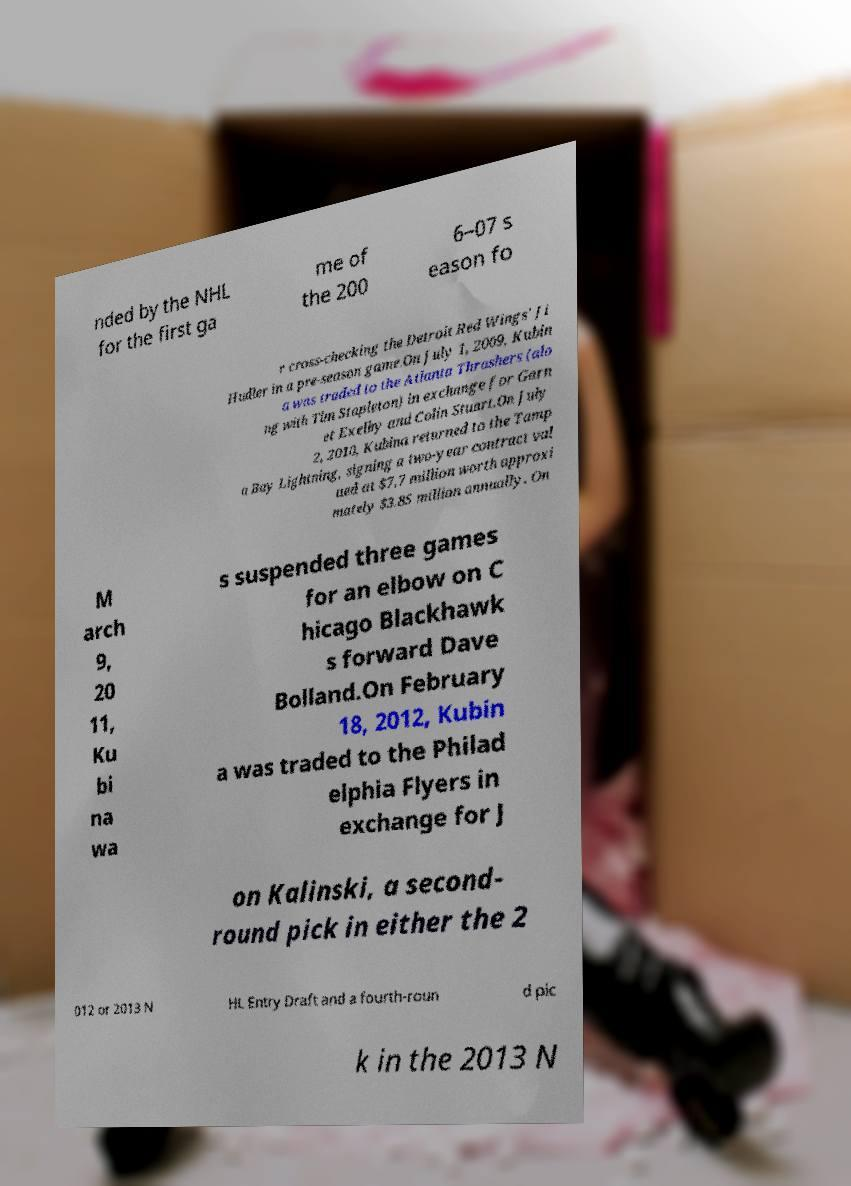Could you assist in decoding the text presented in this image and type it out clearly? nded by the NHL for the first ga me of the 200 6–07 s eason fo r cross-checking the Detroit Red Wings' Ji Hudler in a pre-season game.On July 1, 2009, Kubin a was traded to the Atlanta Thrashers (alo ng with Tim Stapleton) in exchange for Garn et Exelby and Colin Stuart.On July 2, 2010, Kubina returned to the Tamp a Bay Lightning, signing a two-year contract val ued at $7.7 million worth approxi mately $3.85 million annually. On M arch 9, 20 11, Ku bi na wa s suspended three games for an elbow on C hicago Blackhawk s forward Dave Bolland.On February 18, 2012, Kubin a was traded to the Philad elphia Flyers in exchange for J on Kalinski, a second- round pick in either the 2 012 or 2013 N HL Entry Draft and a fourth-roun d pic k in the 2013 N 